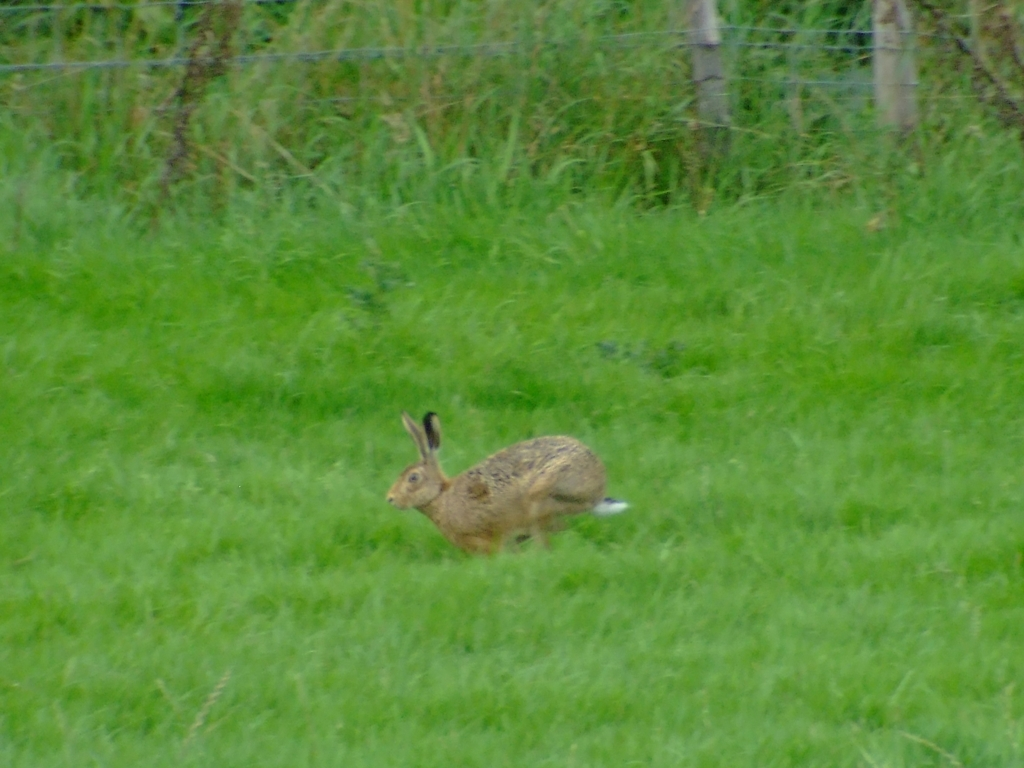Is there any noise in the image? Upon inspecting the image, it's evident that there is a noticeable amount of noise, which is affecting the clarity and crispness. This is characterized by the apparent graininess seen throughout, particularly in the areas of the grass and background. It suggests either a high ISO setting was used during capture or the image is under low light conditions. 